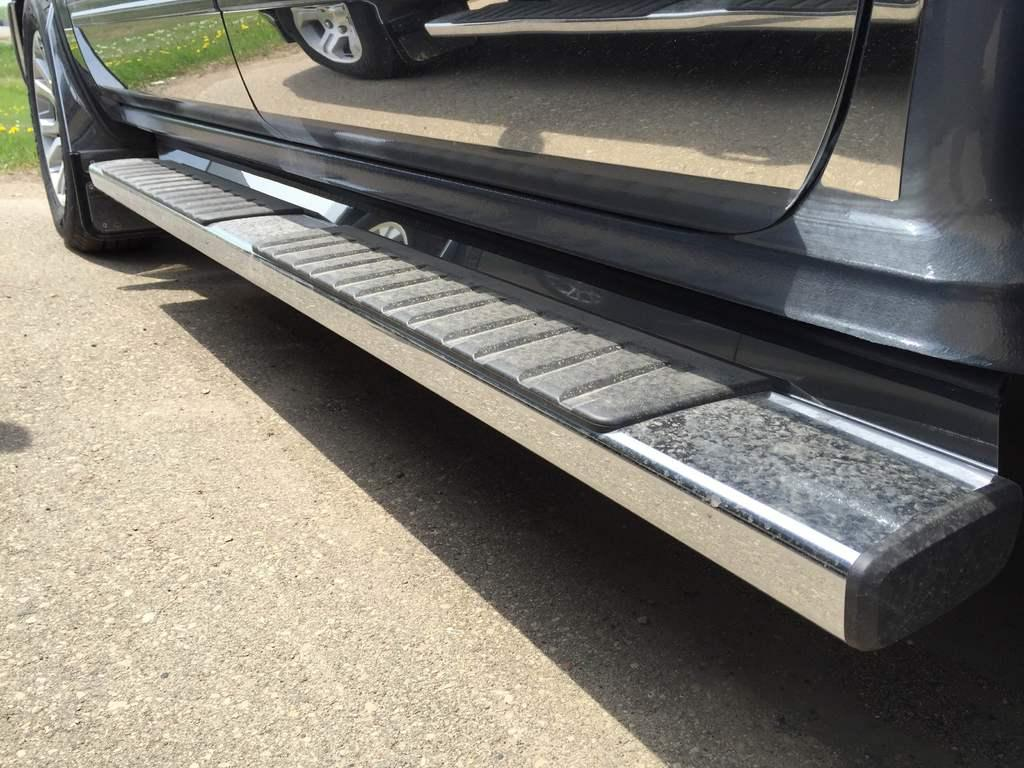What is on the road in the image? There is a vehicle on the road in the image. What else can be seen in the image besides the vehicle? There are flowering plants in the image. Can you tell if the image was taken during the day or night? The image was likely taken during the day. How many cents are visible on the vehicle in the image? There is no mention of any currency or cents in the image; it only features a vehicle and flowering plants. 